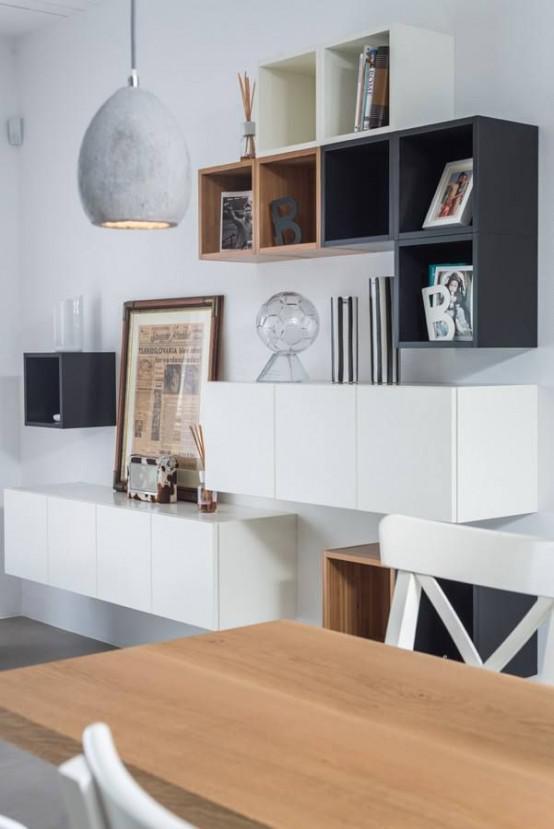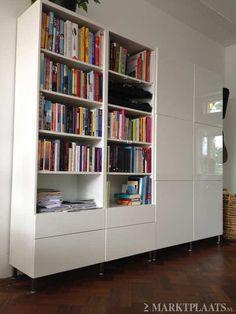The first image is the image on the left, the second image is the image on the right. Analyze the images presented: Is the assertion "There is one big white bookshelf, with pink back panels and two wicker basket on the bottle left shelf." valid? Answer yes or no. No. 